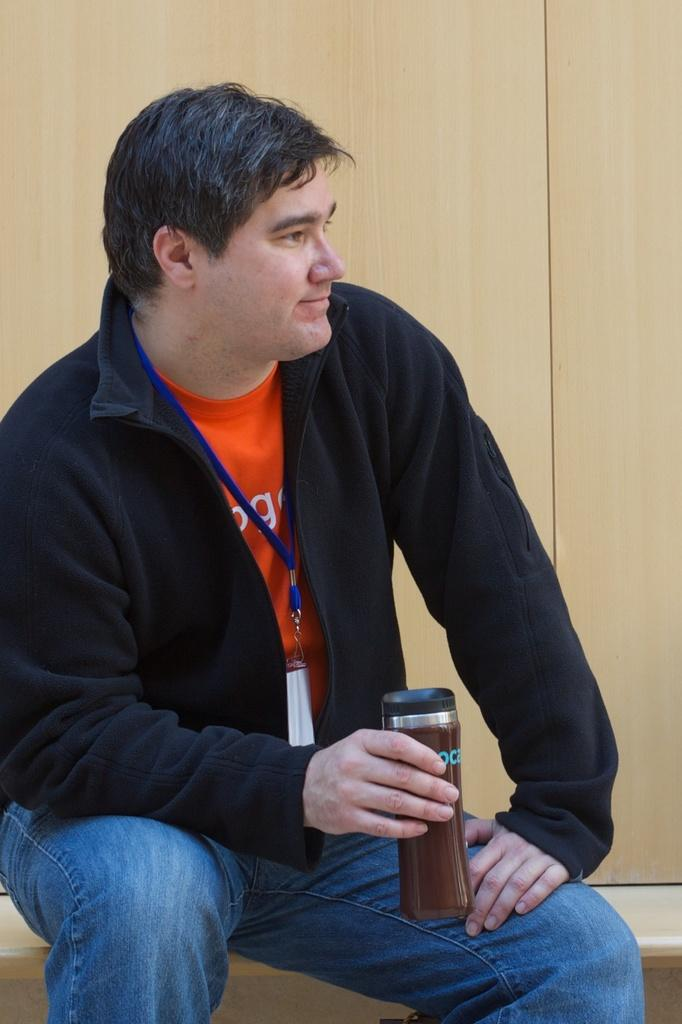What is the person in the image doing? The person is sitting in the image. What is the person holding in the image? The person is holding a bottle. What can be seen in the background of the image? There is an object in the background that looks like a wall. How many icicles are hanging from the person's wrist in the image? There are no icicles present in the image, and the person's wrist is not visible. 